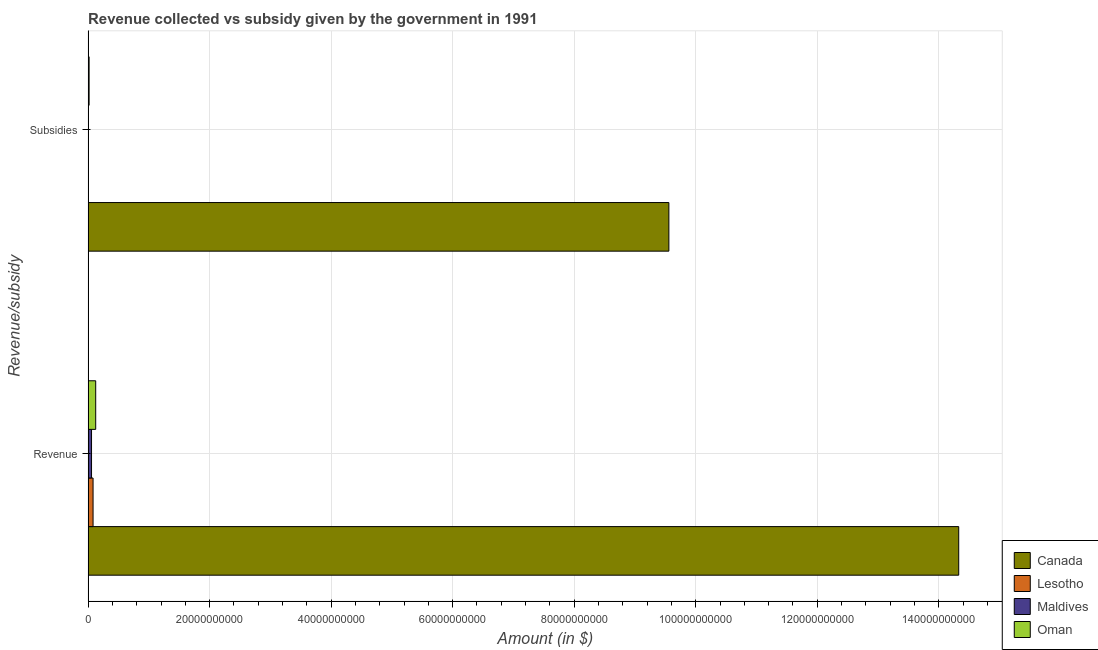How many different coloured bars are there?
Offer a terse response. 4. How many groups of bars are there?
Offer a terse response. 2. How many bars are there on the 2nd tick from the top?
Offer a terse response. 4. How many bars are there on the 1st tick from the bottom?
Give a very brief answer. 4. What is the label of the 1st group of bars from the top?
Your answer should be very brief. Subsidies. What is the amount of revenue collected in Oman?
Ensure brevity in your answer.  1.25e+09. Across all countries, what is the maximum amount of subsidies given?
Provide a short and direct response. 9.56e+1. Across all countries, what is the minimum amount of subsidies given?
Give a very brief answer. 4.80e+06. In which country was the amount of revenue collected minimum?
Offer a very short reply. Maldives. What is the total amount of subsidies given in the graph?
Ensure brevity in your answer.  9.58e+1. What is the difference between the amount of revenue collected in Maldives and that in Canada?
Give a very brief answer. -1.43e+11. What is the difference between the amount of revenue collected in Lesotho and the amount of subsidies given in Oman?
Make the answer very short. 6.53e+08. What is the average amount of revenue collected per country?
Offer a very short reply. 3.65e+1. What is the difference between the amount of subsidies given and amount of revenue collected in Lesotho?
Offer a very short reply. -7.54e+08. In how many countries, is the amount of revenue collected greater than 112000000000 $?
Your answer should be compact. 1. What is the ratio of the amount of revenue collected in Canada to that in Oman?
Give a very brief answer. 114.25. Is the amount of subsidies given in Maldives less than that in Oman?
Your answer should be compact. Yes. In how many countries, is the amount of subsidies given greater than the average amount of subsidies given taken over all countries?
Ensure brevity in your answer.  1. What does the 2nd bar from the top in Revenue represents?
Make the answer very short. Maldives. How many bars are there?
Offer a terse response. 8. How many countries are there in the graph?
Ensure brevity in your answer.  4. What is the difference between two consecutive major ticks on the X-axis?
Your answer should be compact. 2.00e+1. Does the graph contain grids?
Make the answer very short. Yes. How are the legend labels stacked?
Provide a succinct answer. Vertical. What is the title of the graph?
Your answer should be compact. Revenue collected vs subsidy given by the government in 1991. Does "Faeroe Islands" appear as one of the legend labels in the graph?
Make the answer very short. No. What is the label or title of the X-axis?
Your answer should be very brief. Amount (in $). What is the label or title of the Y-axis?
Make the answer very short. Revenue/subsidy. What is the Amount (in $) in Canada in Revenue?
Make the answer very short. 1.43e+11. What is the Amount (in $) in Lesotho in Revenue?
Your answer should be compact. 8.20e+08. What is the Amount (in $) in Maldives in Revenue?
Provide a short and direct response. 5.68e+08. What is the Amount (in $) of Oman in Revenue?
Provide a short and direct response. 1.25e+09. What is the Amount (in $) of Canada in Subsidies?
Make the answer very short. 9.56e+1. What is the Amount (in $) of Lesotho in Subsidies?
Your answer should be compact. 6.53e+07. What is the Amount (in $) in Maldives in Subsidies?
Ensure brevity in your answer.  4.80e+06. What is the Amount (in $) in Oman in Subsidies?
Your response must be concise. 1.67e+08. Across all Revenue/subsidy, what is the maximum Amount (in $) in Canada?
Your answer should be very brief. 1.43e+11. Across all Revenue/subsidy, what is the maximum Amount (in $) of Lesotho?
Your answer should be compact. 8.20e+08. Across all Revenue/subsidy, what is the maximum Amount (in $) of Maldives?
Ensure brevity in your answer.  5.68e+08. Across all Revenue/subsidy, what is the maximum Amount (in $) of Oman?
Offer a very short reply. 1.25e+09. Across all Revenue/subsidy, what is the minimum Amount (in $) in Canada?
Your answer should be very brief. 9.56e+1. Across all Revenue/subsidy, what is the minimum Amount (in $) in Lesotho?
Ensure brevity in your answer.  6.53e+07. Across all Revenue/subsidy, what is the minimum Amount (in $) in Maldives?
Give a very brief answer. 4.80e+06. Across all Revenue/subsidy, what is the minimum Amount (in $) of Oman?
Keep it short and to the point. 1.67e+08. What is the total Amount (in $) of Canada in the graph?
Offer a terse response. 2.39e+11. What is the total Amount (in $) in Lesotho in the graph?
Your response must be concise. 8.85e+08. What is the total Amount (in $) of Maldives in the graph?
Provide a short and direct response. 5.72e+08. What is the total Amount (in $) in Oman in the graph?
Your answer should be very brief. 1.42e+09. What is the difference between the Amount (in $) in Canada in Revenue and that in Subsidies?
Your answer should be very brief. 4.77e+1. What is the difference between the Amount (in $) of Lesotho in Revenue and that in Subsidies?
Offer a terse response. 7.54e+08. What is the difference between the Amount (in $) in Maldives in Revenue and that in Subsidies?
Provide a short and direct response. 5.63e+08. What is the difference between the Amount (in $) of Oman in Revenue and that in Subsidies?
Offer a terse response. 1.09e+09. What is the difference between the Amount (in $) of Canada in Revenue and the Amount (in $) of Lesotho in Subsidies?
Provide a short and direct response. 1.43e+11. What is the difference between the Amount (in $) of Canada in Revenue and the Amount (in $) of Maldives in Subsidies?
Provide a succinct answer. 1.43e+11. What is the difference between the Amount (in $) in Canada in Revenue and the Amount (in $) in Oman in Subsidies?
Provide a succinct answer. 1.43e+11. What is the difference between the Amount (in $) in Lesotho in Revenue and the Amount (in $) in Maldives in Subsidies?
Make the answer very short. 8.15e+08. What is the difference between the Amount (in $) of Lesotho in Revenue and the Amount (in $) of Oman in Subsidies?
Ensure brevity in your answer.  6.53e+08. What is the difference between the Amount (in $) of Maldives in Revenue and the Amount (in $) of Oman in Subsidies?
Keep it short and to the point. 4.01e+08. What is the average Amount (in $) of Canada per Revenue/subsidy?
Your answer should be very brief. 1.19e+11. What is the average Amount (in $) of Lesotho per Revenue/subsidy?
Ensure brevity in your answer.  4.42e+08. What is the average Amount (in $) in Maldives per Revenue/subsidy?
Keep it short and to the point. 2.86e+08. What is the average Amount (in $) of Oman per Revenue/subsidy?
Provide a succinct answer. 7.11e+08. What is the difference between the Amount (in $) of Canada and Amount (in $) of Lesotho in Revenue?
Your answer should be compact. 1.42e+11. What is the difference between the Amount (in $) of Canada and Amount (in $) of Maldives in Revenue?
Ensure brevity in your answer.  1.43e+11. What is the difference between the Amount (in $) of Canada and Amount (in $) of Oman in Revenue?
Your response must be concise. 1.42e+11. What is the difference between the Amount (in $) in Lesotho and Amount (in $) in Maldives in Revenue?
Offer a very short reply. 2.52e+08. What is the difference between the Amount (in $) of Lesotho and Amount (in $) of Oman in Revenue?
Offer a very short reply. -4.35e+08. What is the difference between the Amount (in $) of Maldives and Amount (in $) of Oman in Revenue?
Your answer should be very brief. -6.86e+08. What is the difference between the Amount (in $) in Canada and Amount (in $) in Lesotho in Subsidies?
Give a very brief answer. 9.55e+1. What is the difference between the Amount (in $) in Canada and Amount (in $) in Maldives in Subsidies?
Ensure brevity in your answer.  9.56e+1. What is the difference between the Amount (in $) of Canada and Amount (in $) of Oman in Subsidies?
Provide a succinct answer. 9.54e+1. What is the difference between the Amount (in $) in Lesotho and Amount (in $) in Maldives in Subsidies?
Offer a very short reply. 6.05e+07. What is the difference between the Amount (in $) of Lesotho and Amount (in $) of Oman in Subsidies?
Your response must be concise. -1.02e+08. What is the difference between the Amount (in $) in Maldives and Amount (in $) in Oman in Subsidies?
Make the answer very short. -1.62e+08. What is the ratio of the Amount (in $) of Canada in Revenue to that in Subsidies?
Your response must be concise. 1.5. What is the ratio of the Amount (in $) of Lesotho in Revenue to that in Subsidies?
Ensure brevity in your answer.  12.55. What is the ratio of the Amount (in $) in Maldives in Revenue to that in Subsidies?
Ensure brevity in your answer.  118.27. What is the ratio of the Amount (in $) of Oman in Revenue to that in Subsidies?
Make the answer very short. 7.51. What is the difference between the highest and the second highest Amount (in $) of Canada?
Make the answer very short. 4.77e+1. What is the difference between the highest and the second highest Amount (in $) of Lesotho?
Provide a short and direct response. 7.54e+08. What is the difference between the highest and the second highest Amount (in $) of Maldives?
Offer a very short reply. 5.63e+08. What is the difference between the highest and the second highest Amount (in $) in Oman?
Offer a terse response. 1.09e+09. What is the difference between the highest and the lowest Amount (in $) in Canada?
Make the answer very short. 4.77e+1. What is the difference between the highest and the lowest Amount (in $) of Lesotho?
Your response must be concise. 7.54e+08. What is the difference between the highest and the lowest Amount (in $) of Maldives?
Give a very brief answer. 5.63e+08. What is the difference between the highest and the lowest Amount (in $) in Oman?
Provide a short and direct response. 1.09e+09. 